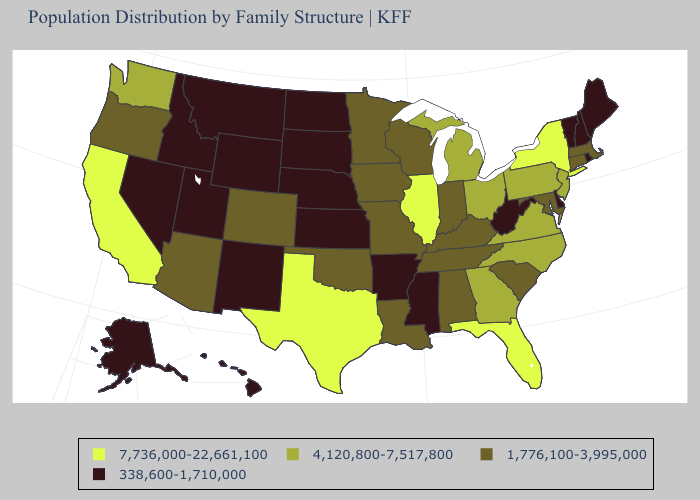Name the states that have a value in the range 338,600-1,710,000?
Be succinct. Alaska, Arkansas, Delaware, Hawaii, Idaho, Kansas, Maine, Mississippi, Montana, Nebraska, Nevada, New Hampshire, New Mexico, North Dakota, Rhode Island, South Dakota, Utah, Vermont, West Virginia, Wyoming. Does Maine have the same value as Arizona?
Short answer required. No. Name the states that have a value in the range 7,736,000-22,661,100?
Quick response, please. California, Florida, Illinois, New York, Texas. What is the highest value in states that border Idaho?
Quick response, please. 4,120,800-7,517,800. What is the highest value in states that border Minnesota?
Quick response, please. 1,776,100-3,995,000. Among the states that border Kansas , which have the lowest value?
Give a very brief answer. Nebraska. Which states have the lowest value in the Northeast?
Give a very brief answer. Maine, New Hampshire, Rhode Island, Vermont. Does New Jersey have a higher value than North Carolina?
Concise answer only. No. Which states have the highest value in the USA?
Short answer required. California, Florida, Illinois, New York, Texas. Name the states that have a value in the range 4,120,800-7,517,800?
Be succinct. Georgia, Michigan, New Jersey, North Carolina, Ohio, Pennsylvania, Virginia, Washington. What is the lowest value in the USA?
Quick response, please. 338,600-1,710,000. Does the first symbol in the legend represent the smallest category?
Give a very brief answer. No. How many symbols are there in the legend?
Answer briefly. 4. Name the states that have a value in the range 7,736,000-22,661,100?
Keep it brief. California, Florida, Illinois, New York, Texas. Does the map have missing data?
Answer briefly. No. 